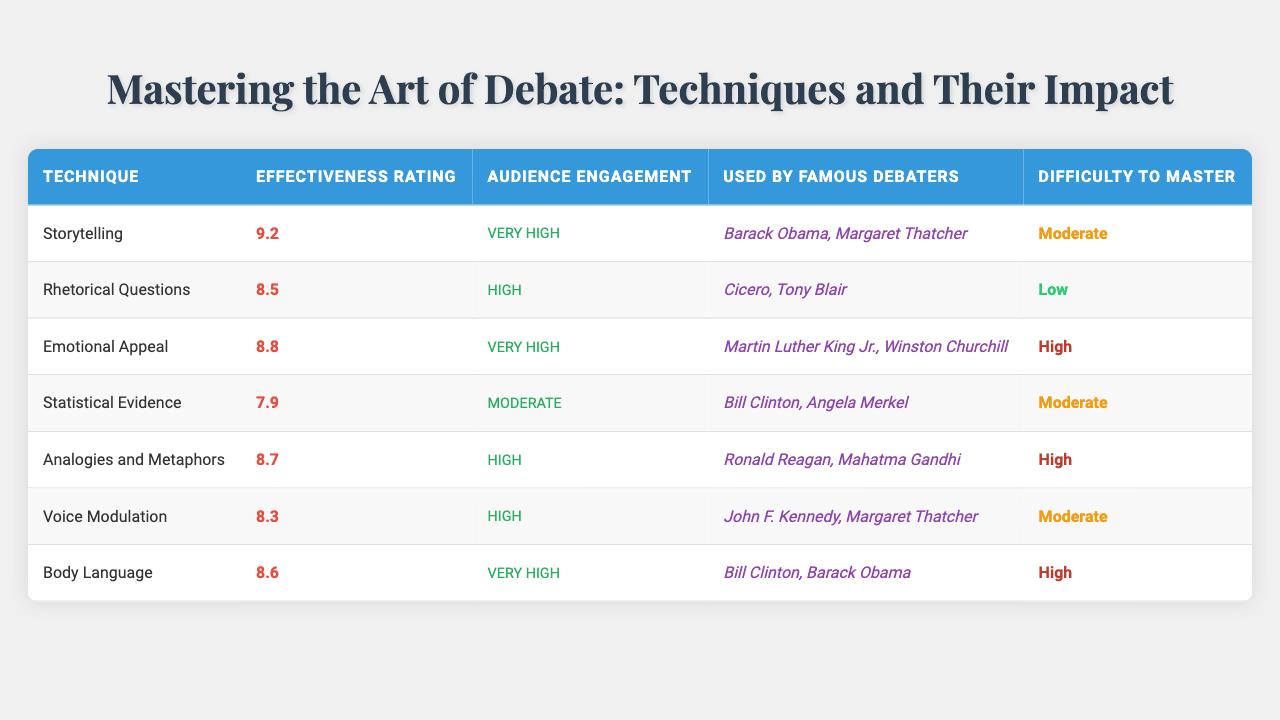What is the effectiveness rating of Storytelling? Locate the row for the technique "Storytelling" in the table, then read the corresponding effectiveness rating in that row, which is 9.2.
Answer: 9.2 Which debate technique has the highest effectiveness rating? Review the effectiveness ratings of all techniques and identify the highest one, which belongs to "Storytelling" at 9.2.
Answer: Storytelling What is the audience engagement level for Emotional Appeal? Find the row for the "Emotional Appeal" technique and check the audience engagement column, which states "Very High".
Answer: Very High How many techniques have a difficulty level classified as High? Review the difficulty levels in the table, counting the number of techniques marked as "High", which are Emotional Appeal, Analogies and Metaphors, and Body Language. That totals to 3.
Answer: 3 Which technique was used by John F. Kennedy? Check the famous debaters listed for "Voice Modulation" to identify if John F. Kennedy is mentioned, which he is.
Answer: Voice Modulation What is the effectiveness rating for Statistical Evidence? Locate "Statistical Evidence" in the table and read the corresponding effectiveness rating from that row, which is 7.9.
Answer: 7.9 Is Voice Modulation a technique with a difficult mastery rating? Find the row for "Voice Modulation" and check the difficulty to master; it indicates "Moderate", confirming it is indeed a technique that is moderately difficult to master.
Answer: Yes Which debate technique has both audience engagement and effectiveness rating 'High'? Examine the table and find techniques that have an audience engagement level of "High" and also check their effectiveness ratings, which reveals two techniques: "Rhetorical Questions" and "Voice Modulation".
Answer: Rhetorical Questions, Voice Modulation What is the average effectiveness rating of the techniques listed? Sum up all the effectiveness ratings (9.2 + 8.5 + 8.8 + 7.9 + 8.7 + 8.3 + 8.6 = 60.0) and divide by the number of techniques (7), giving an average of 60.0/7 = approximately 8.57.
Answer: 8.57 Which technique is known for very high audience engagement and is difficult to master? Look for techniques in the table that combine "Very High" audience engagement and "High" or "Moderate" difficulty to master; "Body Language" fits this criterion.
Answer: Body Language 